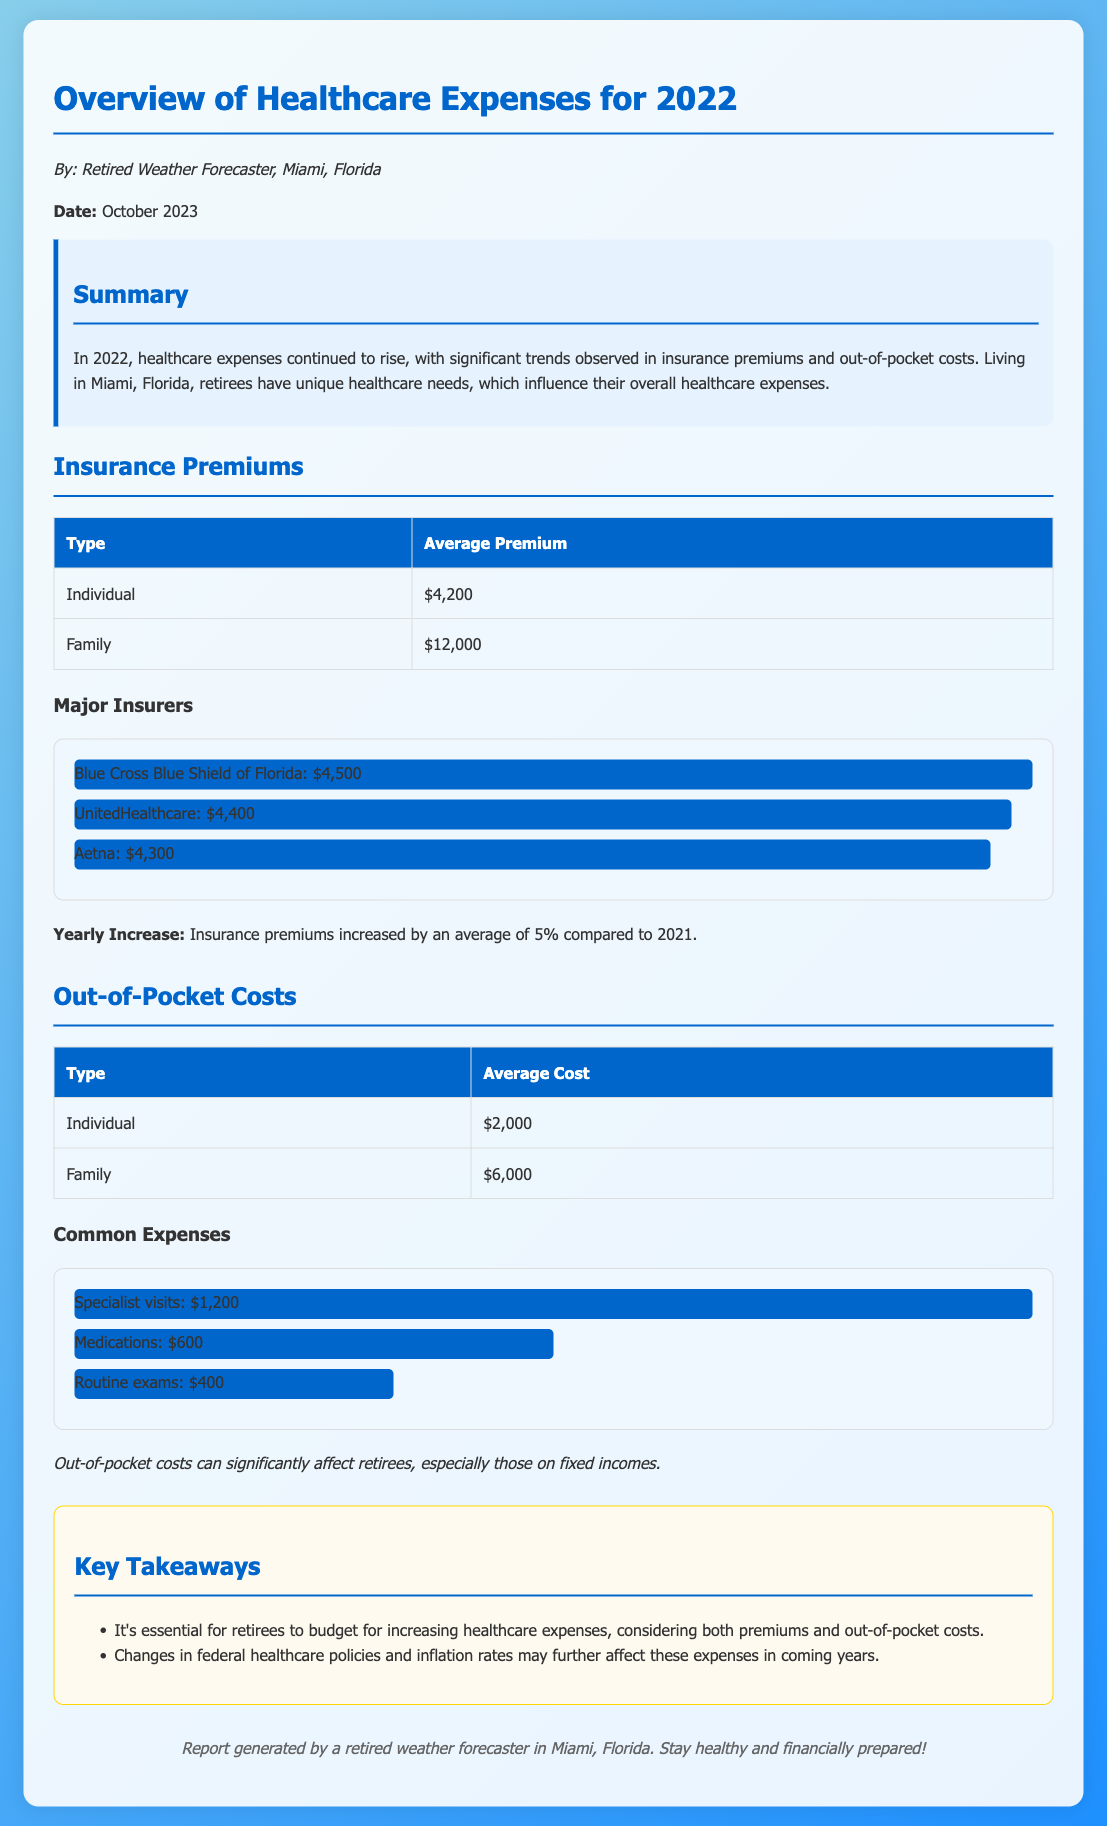What was the average insurance premium for an individual in 2022? The average insurance premium for an individual is specifically stated in the document.
Answer: $4,200 How much did insurance premiums increase compared to 2021? The document provides the percentage increase of insurance premiums over the previous year.
Answer: 5% What was the average out-of-pocket cost for a family in 2022? The average out-of-pocket cost for a family is provided in the document.
Answer: $6,000 Which major insurer had the highest average premium? The document lists major insurers and their average premiums, indicating which one is the highest.
Answer: Blue Cross Blue Shield of Florida: $4,500 What is the average cost of specialist visits? The document includes specific common expenses, pointing out the cost of specialist visits.
Answer: $1,200 How do retiree healthcare needs impact overall expenses in Miami? The document summarizes the influence of retiree healthcare needs on expenses in Miami, noting this context.
Answer: Unique healthcare needs What type of report is presented in the document? This identifies the nature of the document based on its overview and purpose.
Answer: Financial report What key takeaway emphasizes budgeting for healthcare expenses? The document outlines several key takeaways, one of which emphasizes budgeting.
Answer: Budget for increasing healthcare expenses Which category had the lowest average out-of-pocket cost? The document compares different average costs associated with out-of-pocket expenses.
Answer: Routine exams: $400 